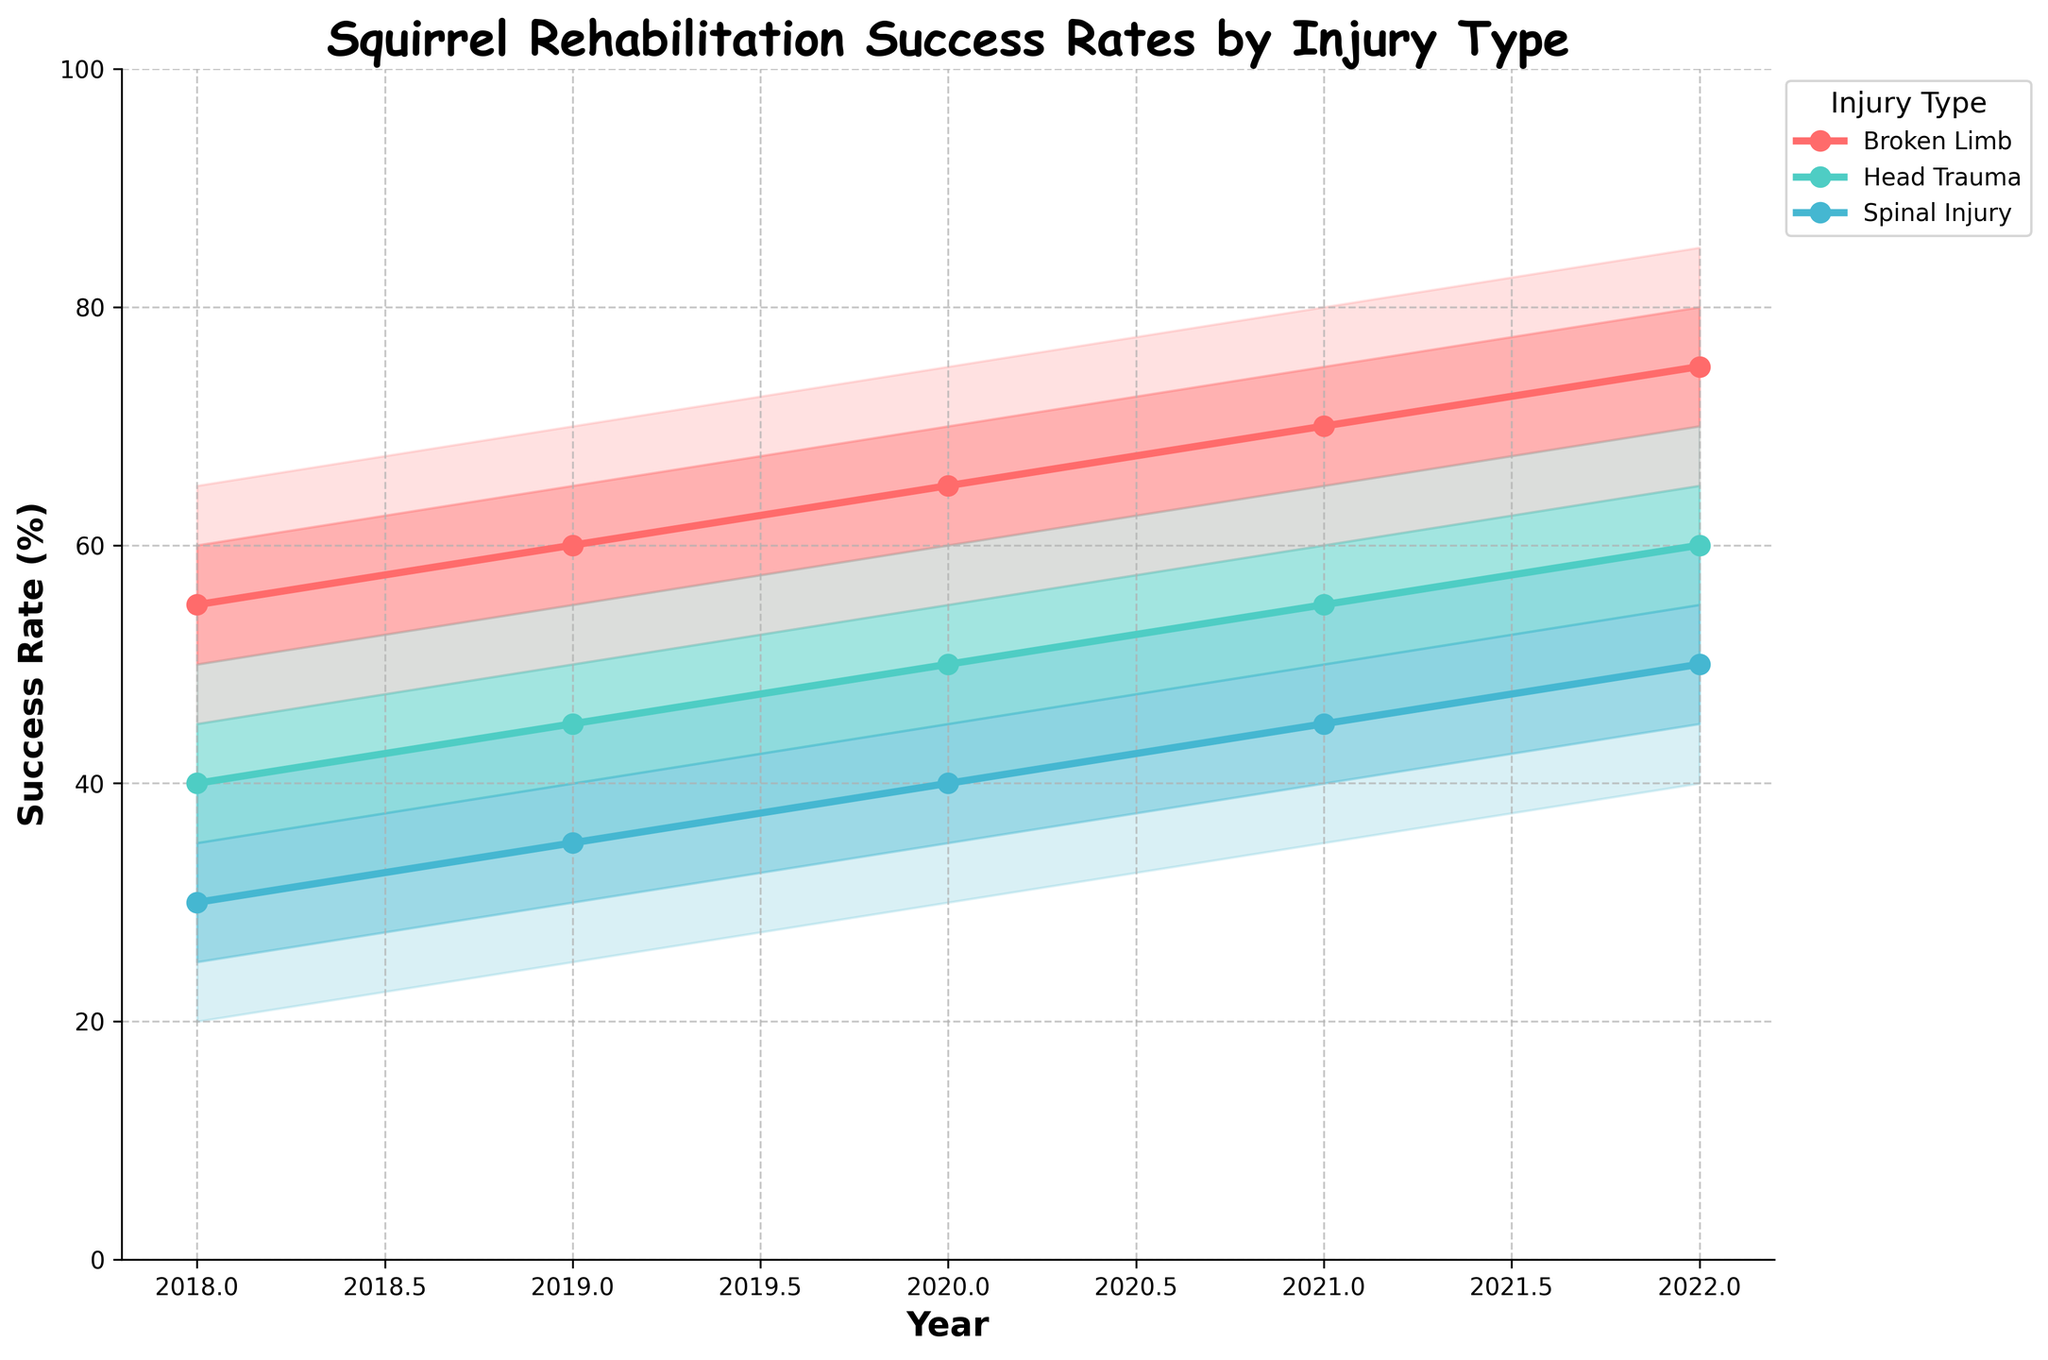How does the success rate for Broken Limb injuries change from 2018 to 2022? Observe the medians for Broken Limb injuries from 2018 to 2022, they are: 55, 60, 65, 70, 75. The rate increases each year.
Answer: It increases What is the median success rate for Head Trauma injuries in 2020? Locate the median value for Head Trauma injuries in the year 2020. It is indicated by the central line and is 50.
Answer: 50 Which injury type shows the highest median success rate in 2021? Compare the median values for all injury types in 2021: Broken Limb (70), Head Trauma (55), Spinal Injury (45). Broken Limb is the highest.
Answer: Broken Limb What is the range of success rates for Spinal Injury in 2019? The range is from the lowest bound to the highest bound for Spinal Injury in 2019. Those values are 25 (lower) and 45 (upper). Subtract 25 from 45 to get the range.
Answer: 20 By how much did the lower bound of Rehabilitation success rates for Head Trauma increase from 2018 to 2022? The lower bound for Head Trauma in 2018 is 30, and in 2022 it is 50. Subtract the 2018 value from the 2022 value: 50 - 30 = 20.
Answer: 20 In which year did all injury types see the highest median success rates? Compare median success rates across all injury types for each year, where 2022 shows medians of 75 (Broken Limb), 60 (Head Trauma), and 50 (Spinal Injury), the highest overall.
Answer: 2022 What is the median success rate for Spinal Injury in 2020? Locate the median value for Spinal Injury injuries in the year 2020. It is indicated by the central line and is 40.
Answer: 40 Which injury type shows the largest increase in median success rates from 2018 to 2022? Calculate the increase for each injury type by subtracting the median value in 2018 from the median value in 2022. Broken Limb: 75 - 55 = 20, Head Trauma: 60 - 40 = 20, Spinal Injury: 50 - 30 = 20. They all show the same increase.
Answer: All three Which injury type has the widest prediction interval in 2020? Look at the distance between the upper and lower bounds for each injury type in 2020. For Broken Limb, it is 75 - 55 = 20. For Head Trauma, it is 60 - 40 = 20. For Spinal Injury, it is 50 - 30 = 20. All intervals are the same width.
Answer: All three 